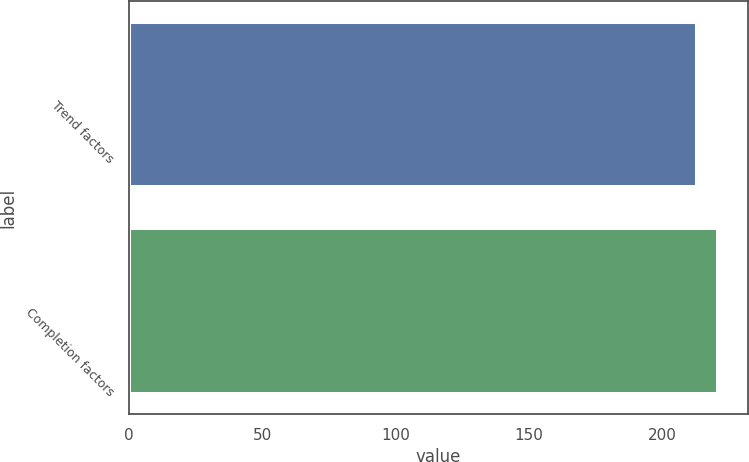<chart> <loc_0><loc_0><loc_500><loc_500><bar_chart><fcel>Trend factors<fcel>Completion factors<nl><fcel>213<fcel>221<nl></chart> 